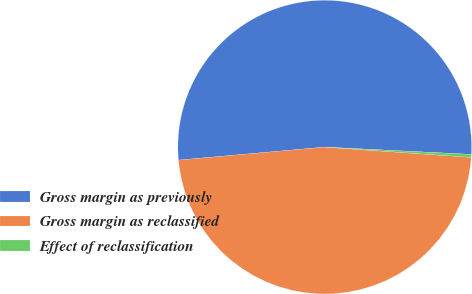Convert chart to OTSL. <chart><loc_0><loc_0><loc_500><loc_500><pie_chart><fcel>Gross margin as previously<fcel>Gross margin as reclassified<fcel>Effect of reclassification<nl><fcel>52.2%<fcel>47.47%<fcel>0.33%<nl></chart> 